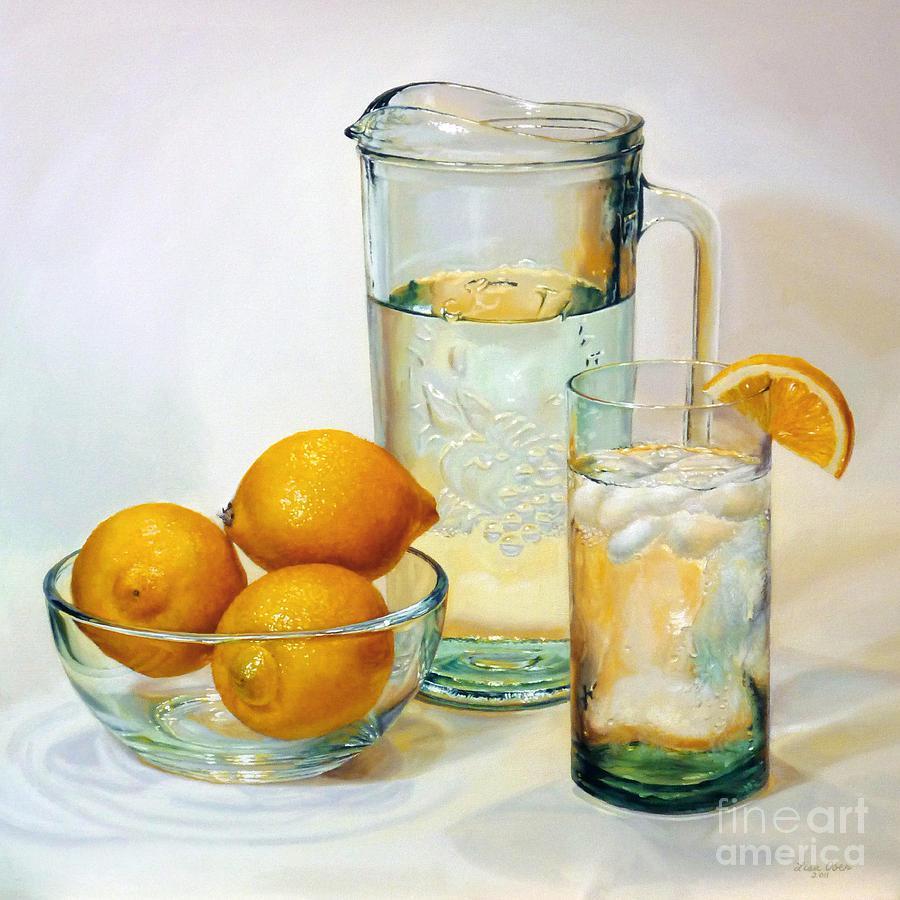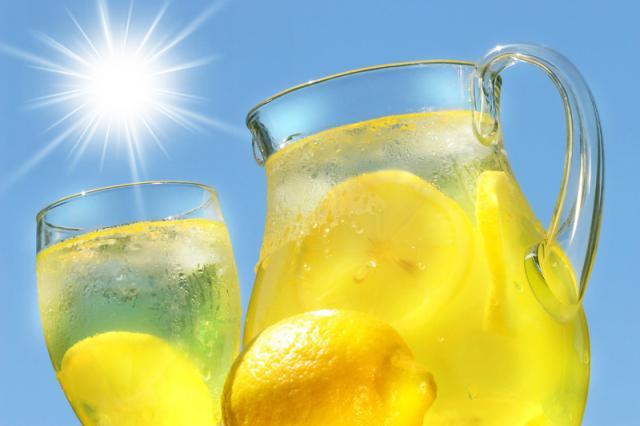The first image is the image on the left, the second image is the image on the right. Given the left and right images, does the statement "The left image includes lemons and a beverage in a drinking glass in front of a pitcher, and the right image includes a pitcher with a rounded bottom." hold true? Answer yes or no. Yes. The first image is the image on the left, the second image is the image on the right. For the images shown, is this caption "In at least one image there is a lemon in front of a rounded lemonade pitcher." true? Answer yes or no. Yes. 